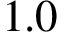<formula> <loc_0><loc_0><loc_500><loc_500>1 . 0</formula> 